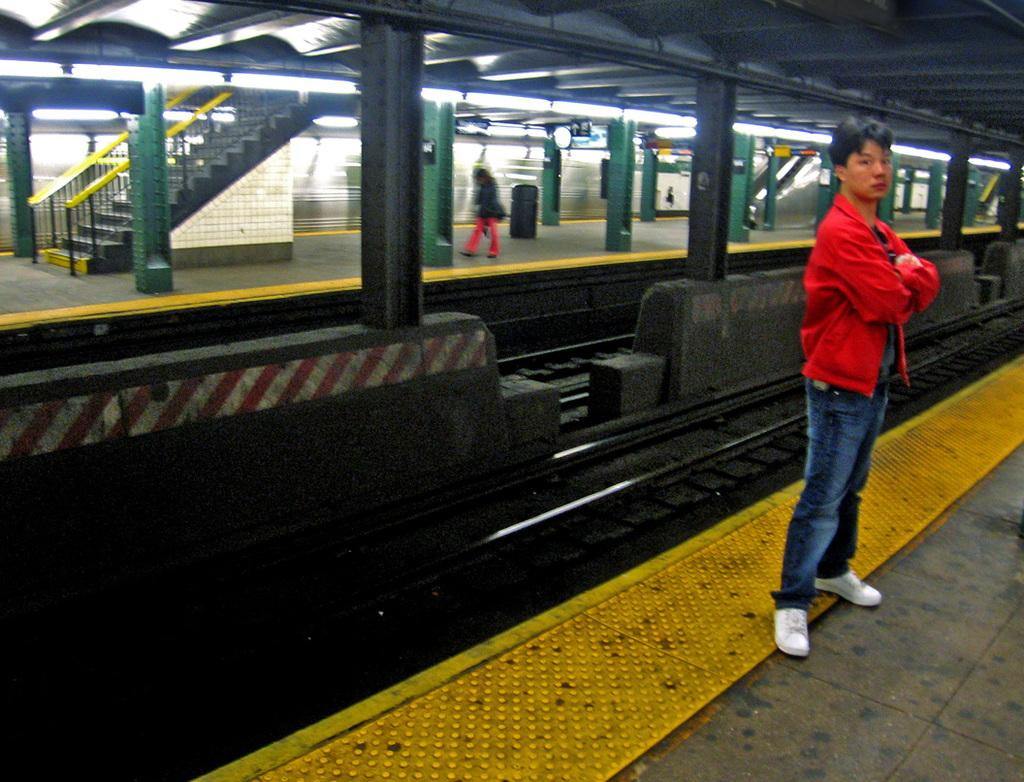What is the person in the image doing? The person is standing on a platform in the image. What can be seen near the person? There are tracks visible in the image. Are there any other platforms in the image? Yes, there is another platform in the image. Can you see a match being lit on the platform in the image? There is no match or any indication of fire in the image. 